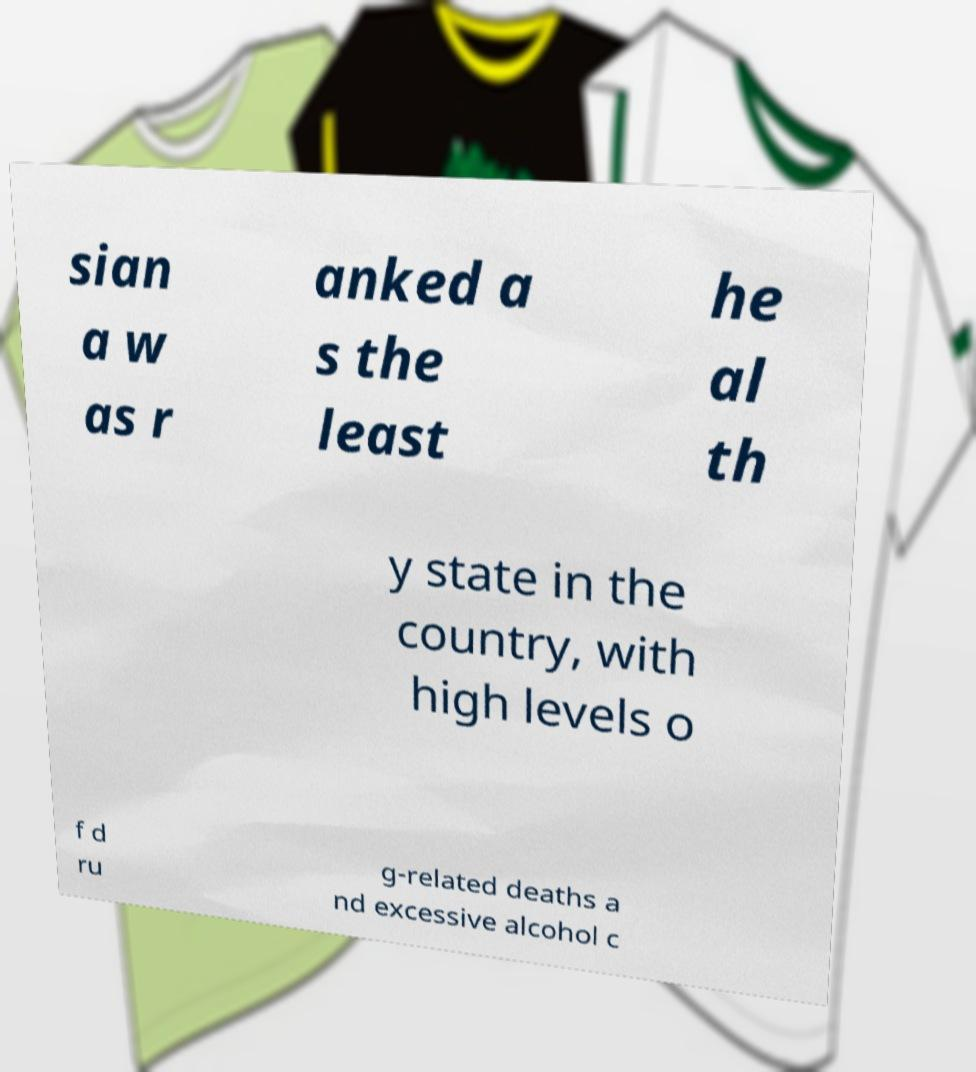Can you read and provide the text displayed in the image?This photo seems to have some interesting text. Can you extract and type it out for me? sian a w as r anked a s the least he al th y state in the country, with high levels o f d ru g-related deaths a nd excessive alcohol c 